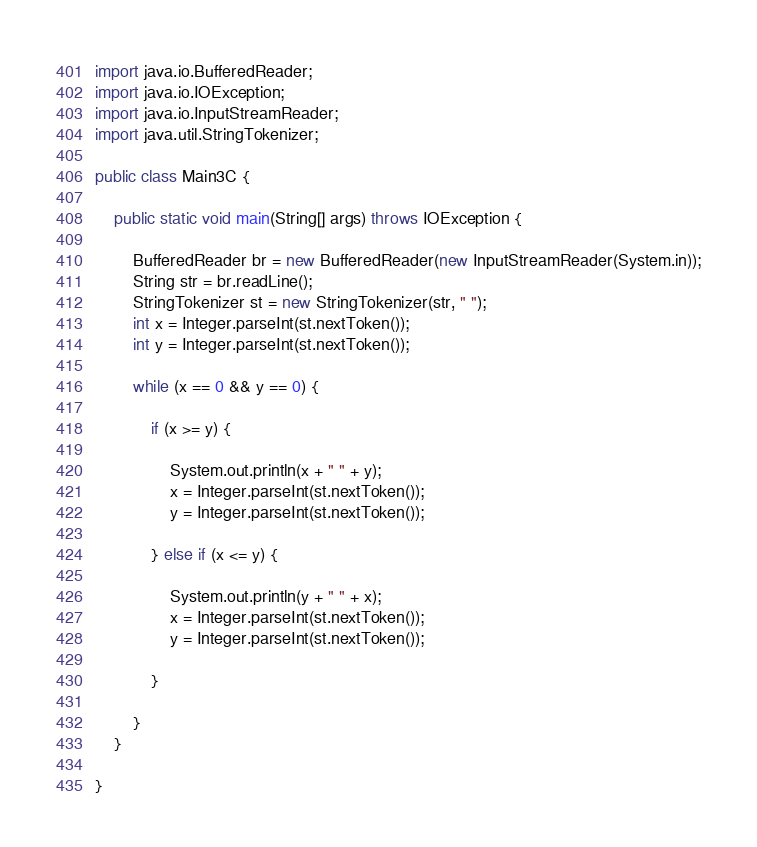Convert code to text. <code><loc_0><loc_0><loc_500><loc_500><_Java_>import java.io.BufferedReader;
import java.io.IOException;
import java.io.InputStreamReader;
import java.util.StringTokenizer;

public class Main3C {

	public static void main(String[] args) throws IOException {

		BufferedReader br = new BufferedReader(new InputStreamReader(System.in));
		String str = br.readLine();
		StringTokenizer st = new StringTokenizer(str, " ");
		int x = Integer.parseInt(st.nextToken());
		int y = Integer.parseInt(st.nextToken());

		while (x == 0 && y == 0) {

			if (x >= y) {

				System.out.println(x + " " + y);
				x = Integer.parseInt(st.nextToken());
				y = Integer.parseInt(st.nextToken());

			} else if (x <= y) {

				System.out.println(y + " " + x);
				x = Integer.parseInt(st.nextToken());
				y = Integer.parseInt(st.nextToken());

			}

		}
	}

}</code> 